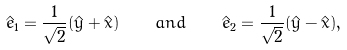<formula> <loc_0><loc_0><loc_500><loc_500>\hat { e } _ { 1 } = \frac { 1 } { \sqrt { 2 } } ( \hat { y } + \hat { x } ) \quad a n d \quad \hat { e } _ { 2 } = \frac { 1 } { \sqrt { 2 } } ( \hat { y } - \hat { x } ) ,</formula> 